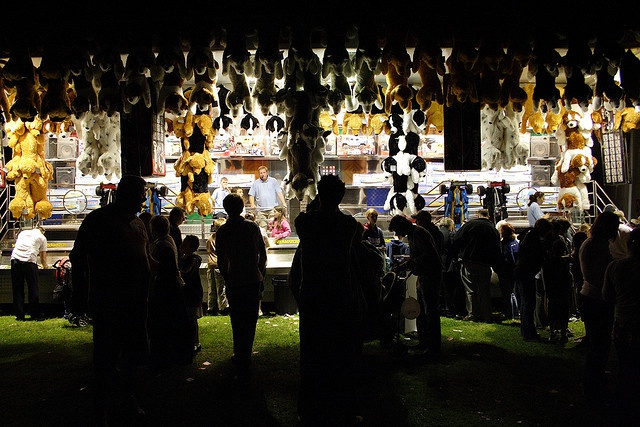Describe the objects in this image and their specific colors. I can see people in black, lightgray, olive, and darkgray tones, people in black, gray, and darkgreen tones, people in black, ivory, gray, and maroon tones, people in black, darkgreen, and olive tones, and people in black, olive, and gray tones in this image. 